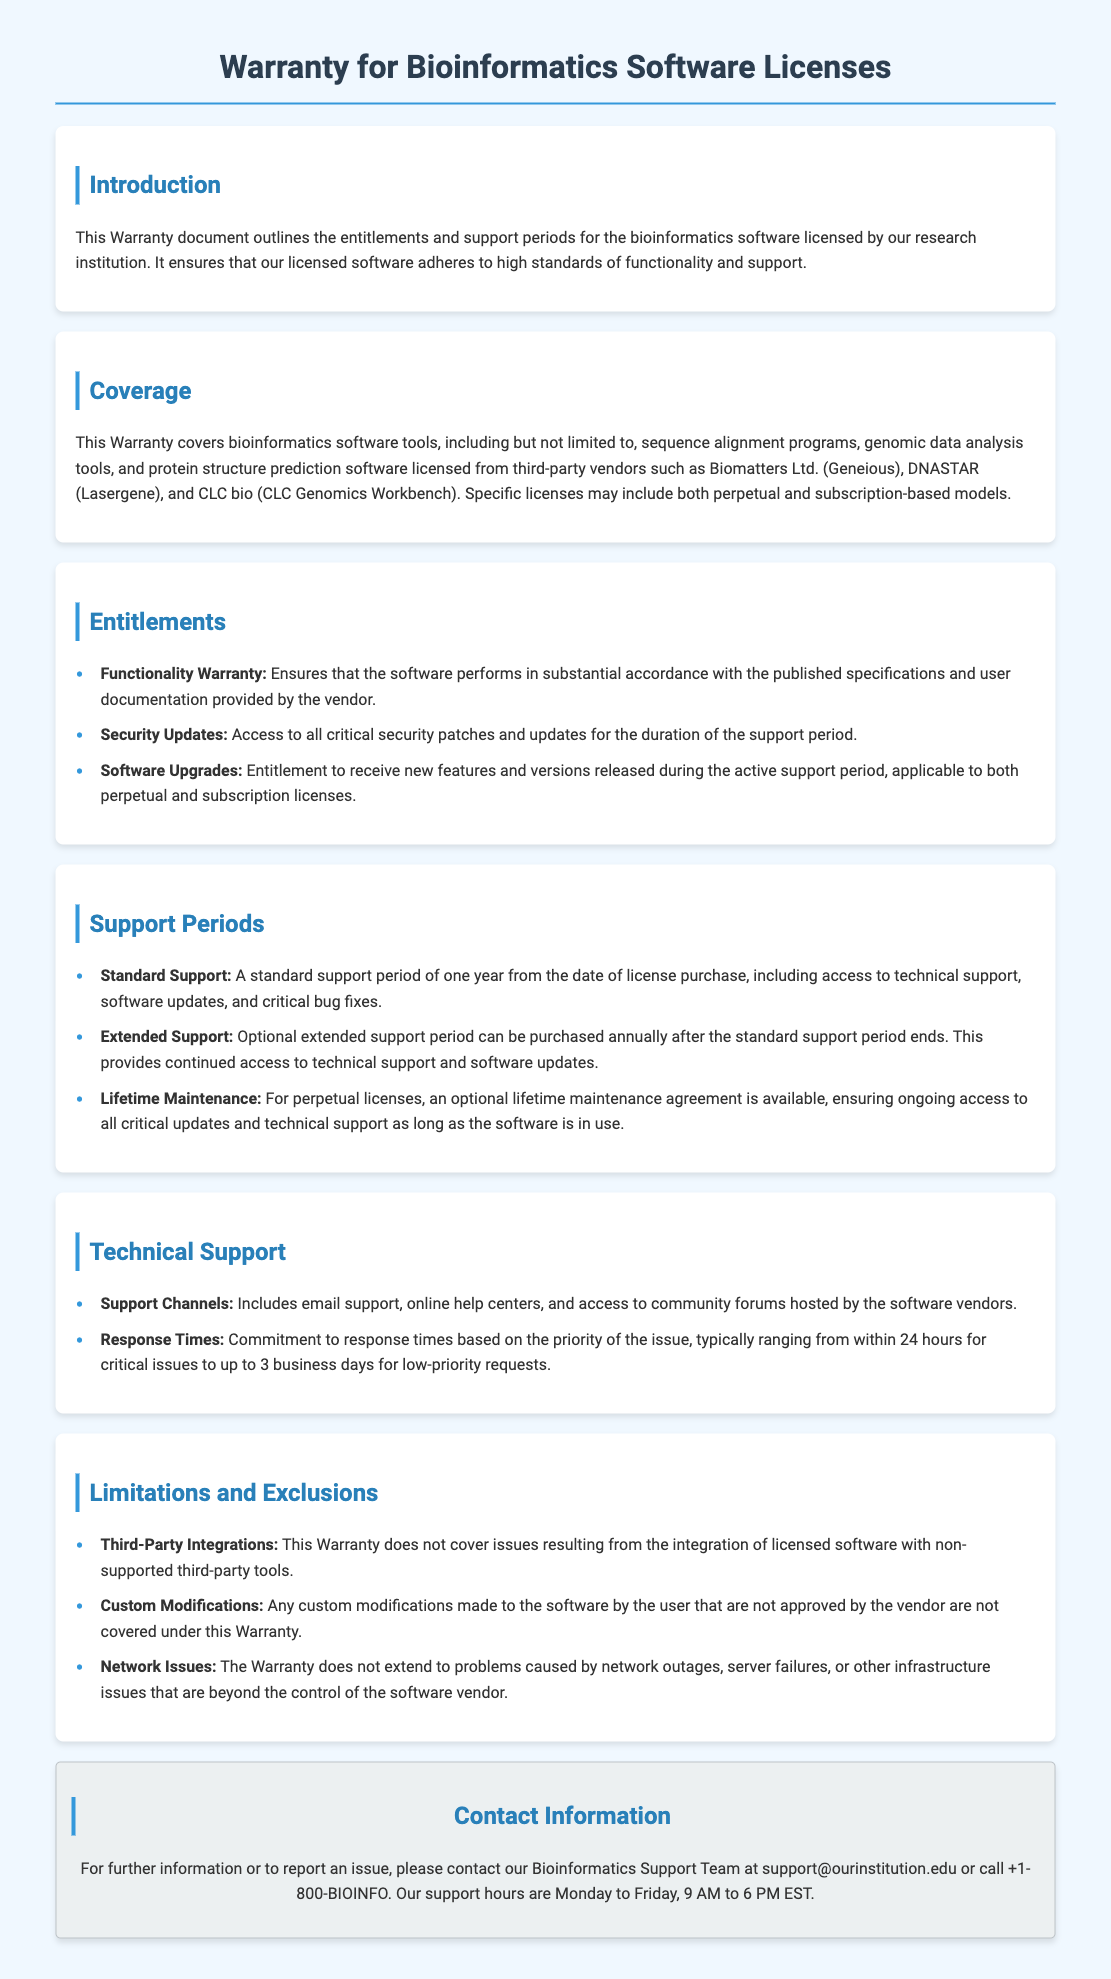What does the Warranty document outline? The Warranty document outlines the entitlements and support periods for the bioinformatics software licensed by the research institution.
Answer: entitlements and support periods What is the duration of the standard support period? The standard support period is stated in the document as one year from the date of license purchase.
Answer: one year What type of support is available during the extended support period? The extended support period provides continued access to technical support and software updates after the standard support ends.
Answer: technical support and software updates Who are some of the third-party vendors mentioned for software licenses? The document mentions specific vendors that include Biomatters Ltd., DNASTAR, and CLC bio.
Answer: Biomatters Ltd., DNASTAR, CLC bio What is not covered by the Warranty regarding third-party integrations? The Warranty does not cover issues resulting from the integration of licensed software with non-supported third-party tools.
Answer: non-supported third-party tools What types of warranty entitlements are mentioned in the document? The document includes functionality warranty, security updates, and software upgrades as entitlements.
Answer: functionality warranty, security updates, software upgrades What are the typical response times for support issues? The document specifies that response times typically range from within 24 hours for critical issues to up to 3 business days for low-priority requests.
Answer: 24 hours to 3 business days What is the optional agreement for perpetual licenses mentioned in the document? The document mentions an optional lifetime maintenance agreement for perpetual licenses.
Answer: lifetime maintenance agreement 